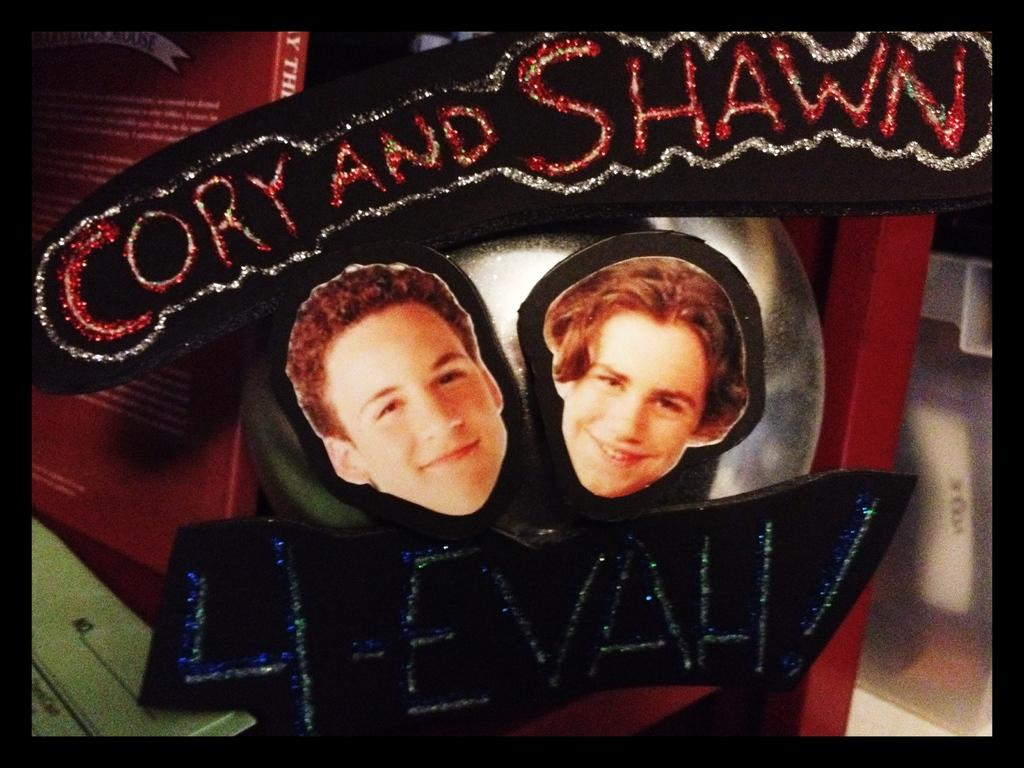What can be seen in the image related to people? There are faces of people in the image. What is the unique feature of the writing in the image? The writing in the image is done with glitters. Where is the book located in the image? The book is on the left side of the image. How would you describe the background of the image? The background portion of the picture is blurred. What type of copper utensil is being used on the stove in the image? There is no stove or copper utensil present in the image. 